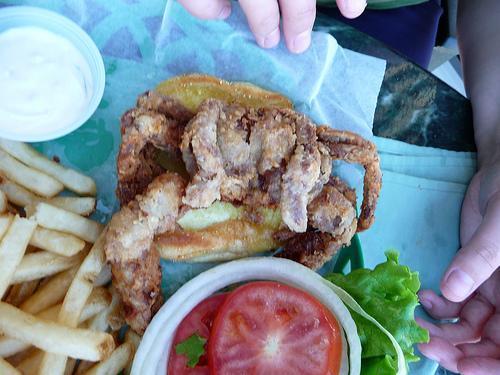How many tomato slices are there?
Give a very brief answer. 2. How many slices of onion are there?
Give a very brief answer. 3. 